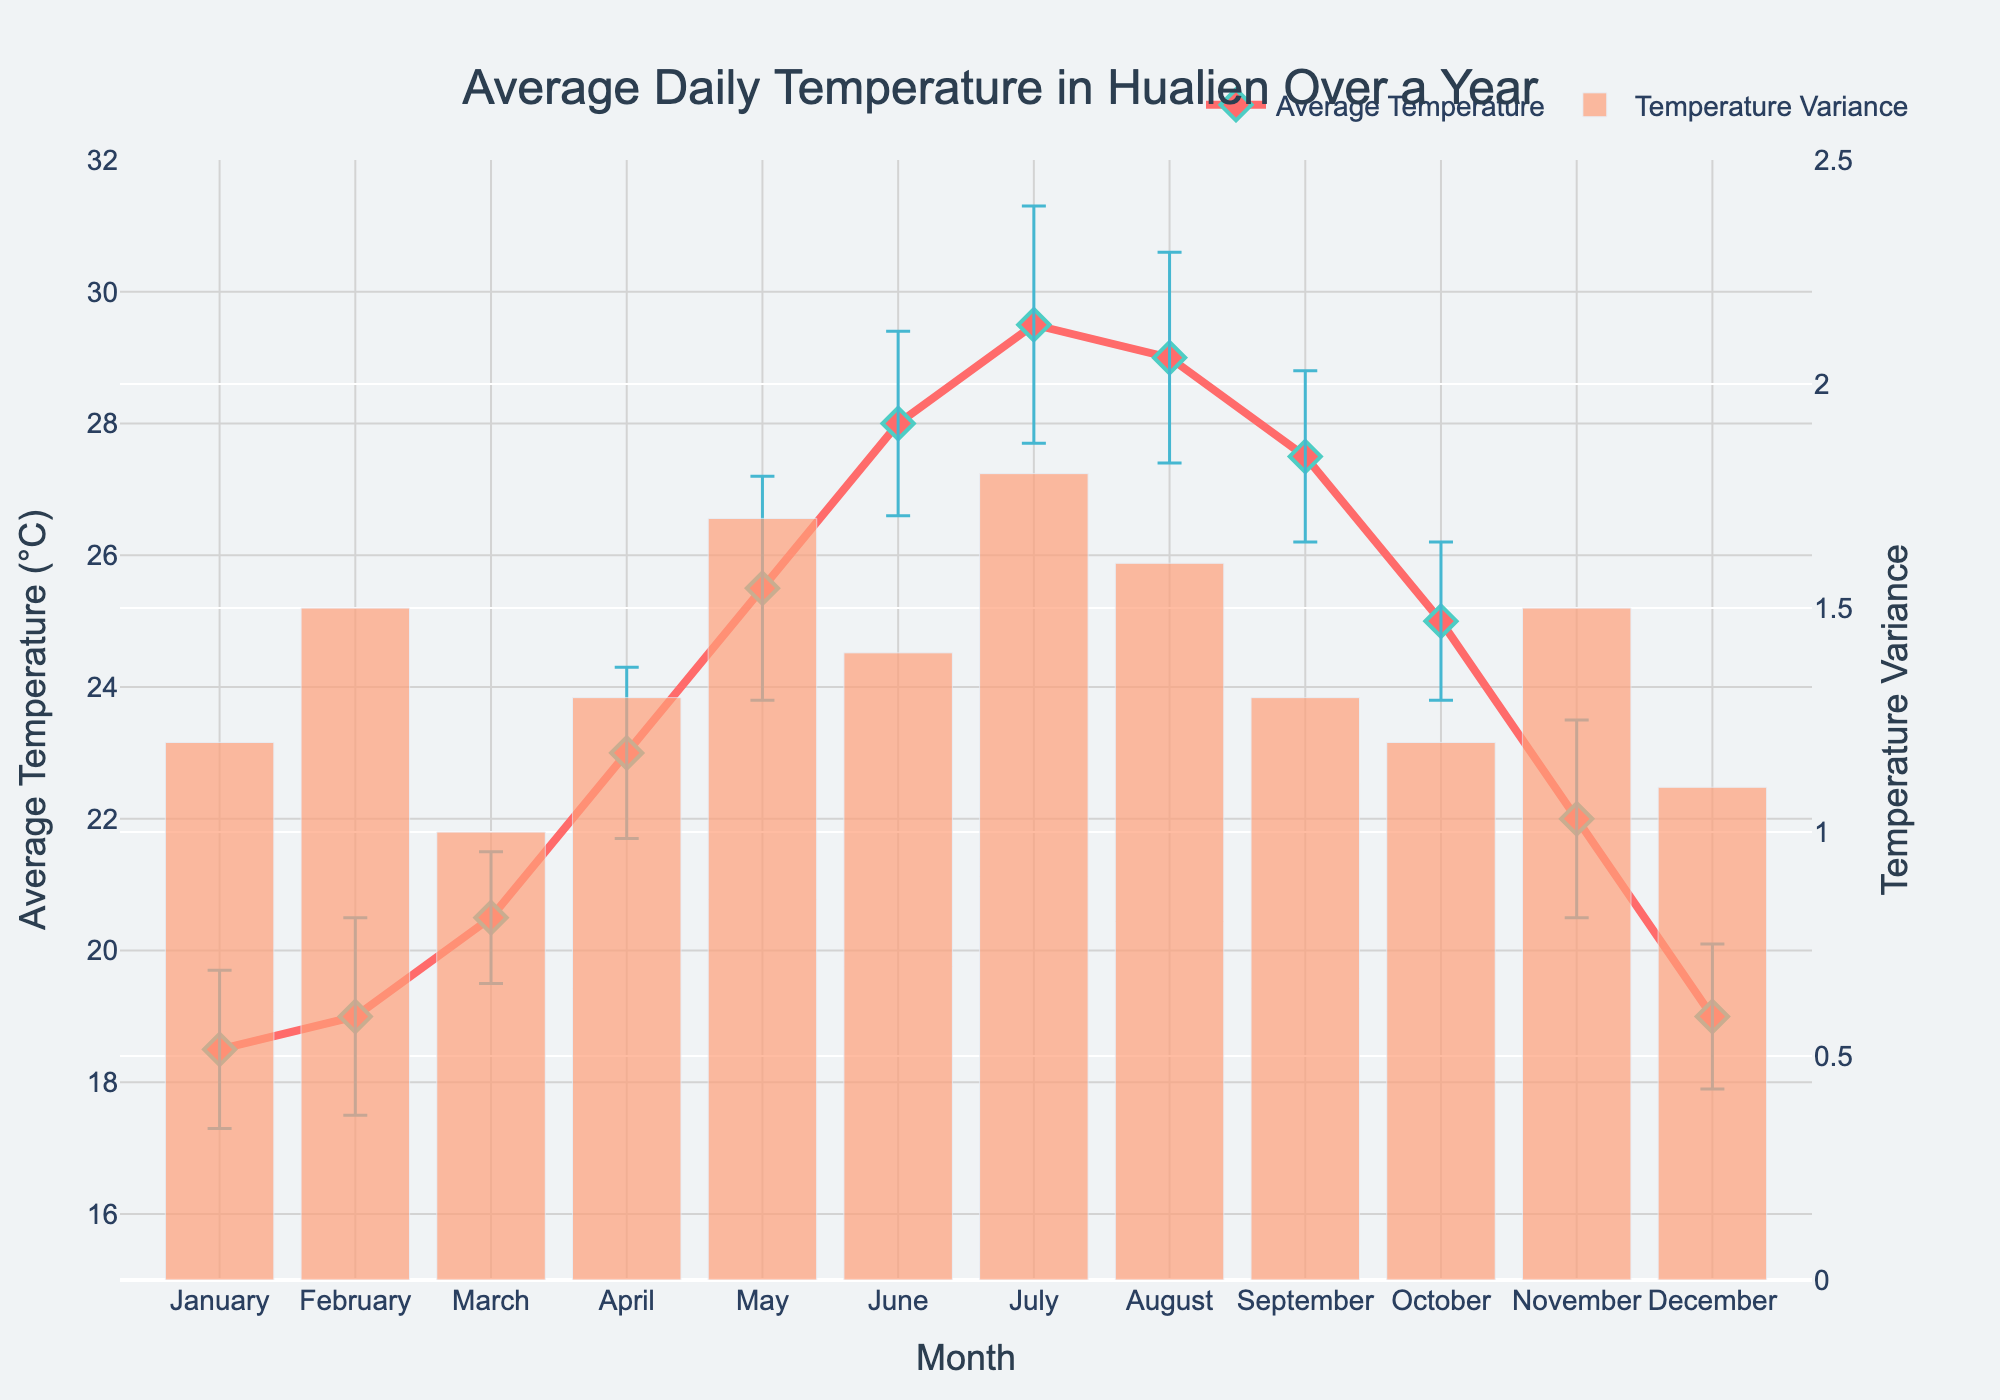Which month has the highest average daily temperature? By observing the line representing average daily temperature, we see that July has the highest point.
Answer: July What is the average daily temperature in February? Referring to the corresponding point on the line plot for February, the average daily temperature is 19.0.
Answer: 19.0°C How does the temperature variance in April compare to that in August? The bar for April is slightly lower than the bar for August. Specifically, April has a variance of 1.3, while August has a variance of 1.6.
Answer: April's variance is lower than August's Which month has the smallest temperature variance? The bar plot indicates that March has the smallest temperature variance at 1.0.
Answer: March What range do the error bars cover for the average daily temperature in May? In May, the average daily temperature is 25.5°C with a variance of 1.7. Therefore, the range covered by the error bars is approximately 25.5 ± 1.7, which is 23.8°C to 27.2°C.
Answer: 23.8°C to 27.2°C Which months have an average daily temperature greater than 25°C? From the line plot, May (25.5), June (28.0), July (29.5), August (29.0), and September (27.5) all have average daily temperatures greater than 25°C.
Answer: May, June, July, August, September Is the temperature variance in January greater than in November? The temperature variance in January is 1.2, which is less than the temperature variance in November of 1.5.
Answer: No What is the difference between the highest and lowest average daily temperature? The highest average daily temperature is in July at 29.5°C, and the lowest is in January at 18.5°C. The difference is 29.5 - 18.5 = 11.0°C.
Answer: 11.0°C Is there any month where the error bar completely overlaps with another month? The error bars of February and December (both centered around 19.0°C and with variances of 1.5 and 1.1 respectively) overlap each other. This means the temperature ranges from approximately 17.5°C to 20.5°C for February and 17.9°C to 20.1°C for December, creating an overlap.
Answer: Yes 